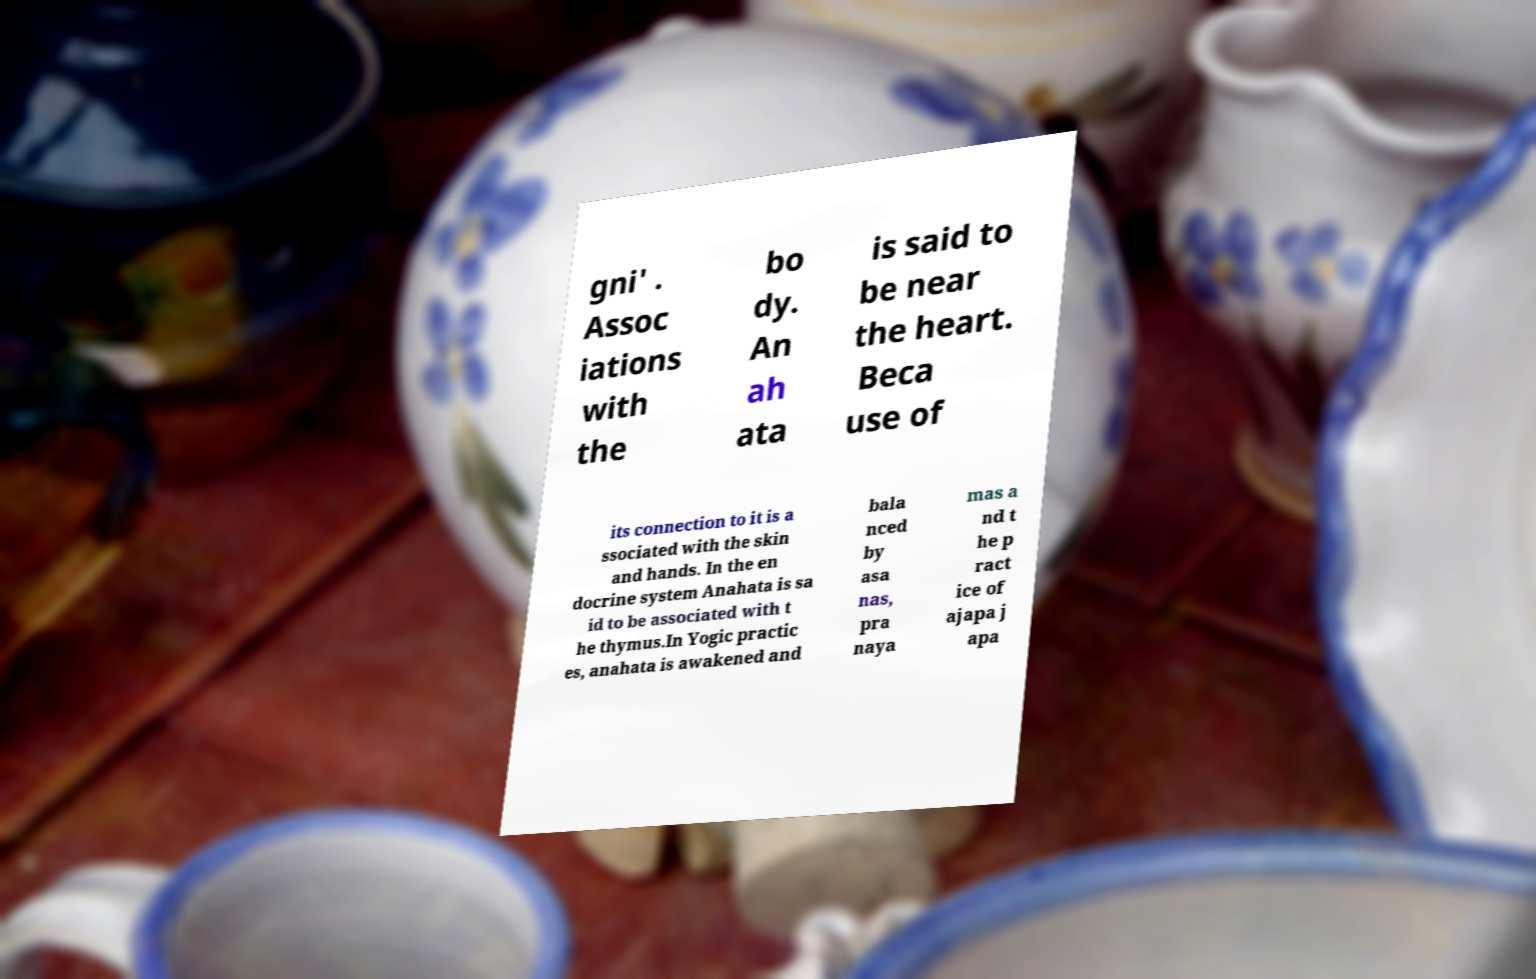I need the written content from this picture converted into text. Can you do that? gni' . Assoc iations with the bo dy. An ah ata is said to be near the heart. Beca use of its connection to it is a ssociated with the skin and hands. In the en docrine system Anahata is sa id to be associated with t he thymus.In Yogic practic es, anahata is awakened and bala nced by asa nas, pra naya mas a nd t he p ract ice of ajapa j apa 